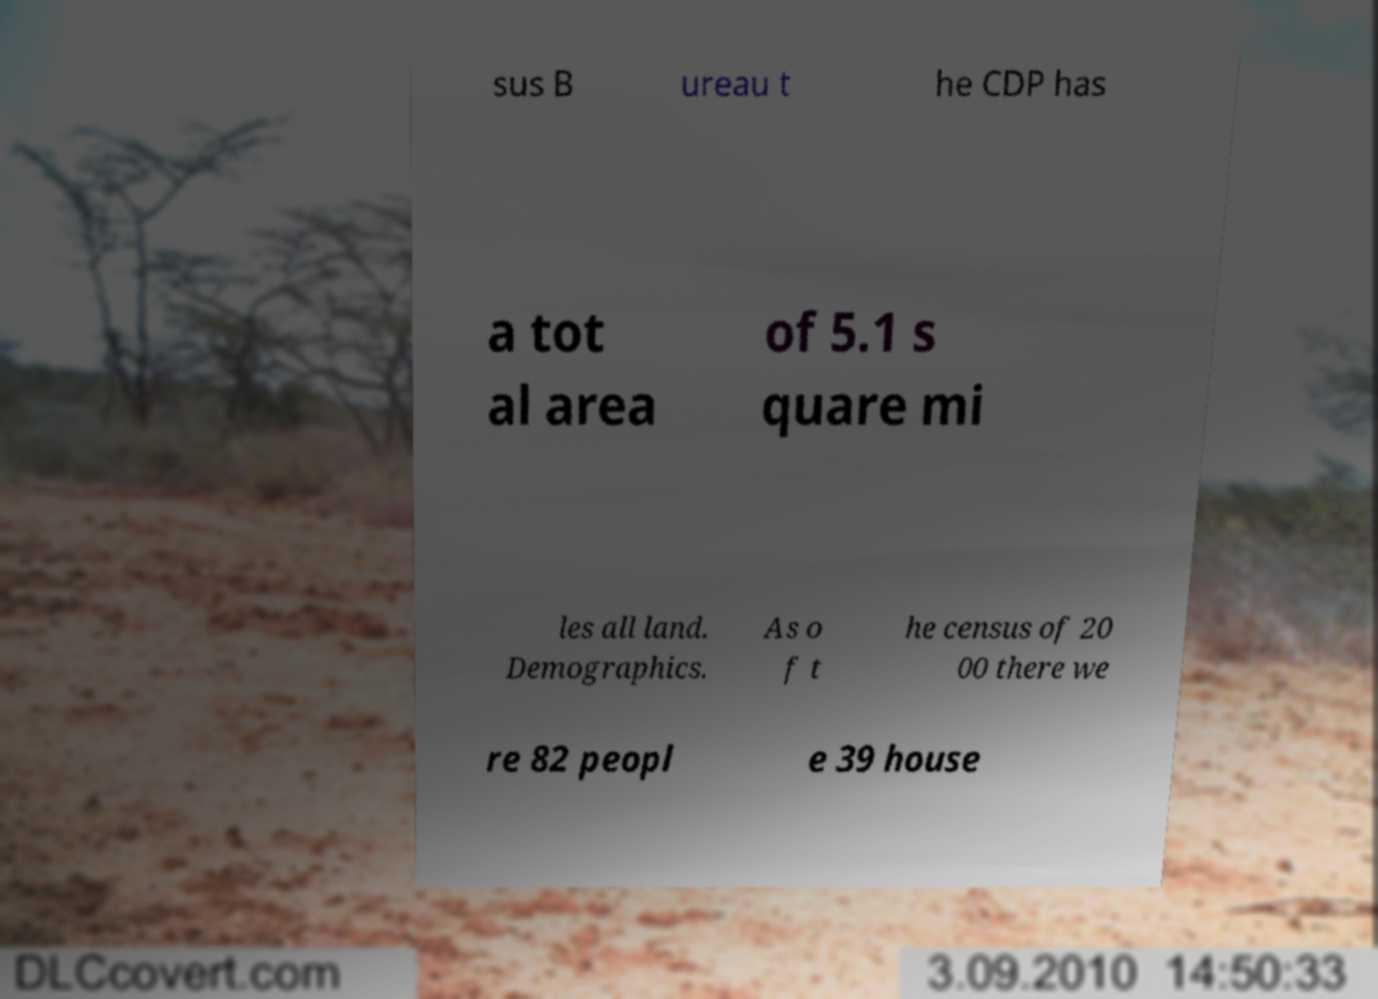Could you extract and type out the text from this image? sus B ureau t he CDP has a tot al area of 5.1 s quare mi les all land. Demographics. As o f t he census of 20 00 there we re 82 peopl e 39 house 